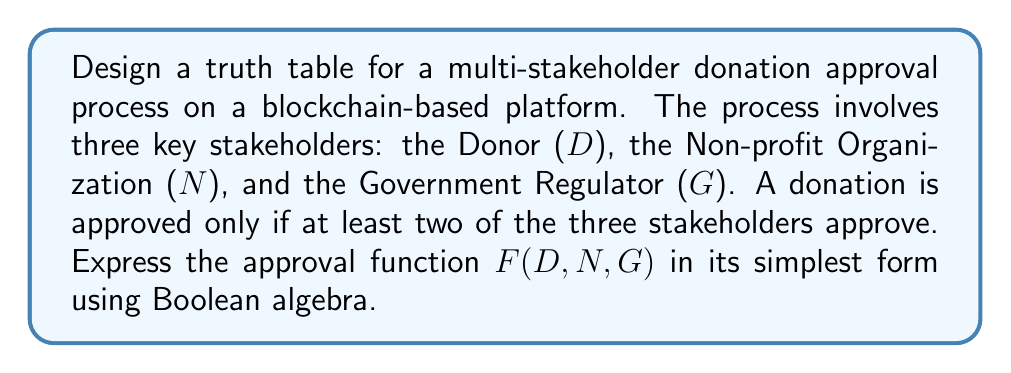Could you help me with this problem? Let's approach this step-by-step:

1) First, we need to create a truth table for all possible combinations of D, N, and G:

   D | N | G | F(D,N,G)
   0 | 0 | 0 |    0
   0 | 0 | 1 |    0
   0 | 1 | 0 |    0
   0 | 1 | 1 |    1
   1 | 0 | 0 |    0
   1 | 0 | 1 |    1
   1 | 1 | 0 |    1
   1 | 1 | 1 |    1

2) From this truth table, we can write the function as a sum of products (SOP):

   $$F(D,N,G) = \overline{D}NG + D\overline{N}G + DN\overline{G} + DNG$$

3) This can be simplified using Boolean algebra laws:

   $$F(D,N,G) = \overline{D}NG + D\overline{N}G + DN\overline{G} + DNG$$
   $$= NG(D + \overline{D}) + D(N\overline{G} + \overline{N}G)$$
   $$= NG + D(N\overline{G} + \overline{N}G)$$
   $$= NG + DN\overline{G} + D\overline{N}G$$

4) This is the simplest SOP form of the function. However, we can express it more compactly using the majority function:

   $$F(D,N,G) = (D \land N) \lor (D \land G) \lor (N \land G)$$

This expression means that the function is true if at least two of D, N, and G are true, which matches our original requirement.
Answer: $F(D,N,G) = (D \land N) \lor (D \land G) \lor (N \land G)$ 